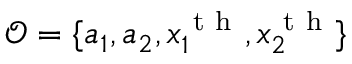<formula> <loc_0><loc_0><loc_500><loc_500>\mathcal { O } = \{ a _ { 1 } , a _ { 2 } , x _ { 1 } ^ { t h } , x _ { 2 } ^ { t h } \}</formula> 